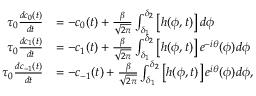<formula> <loc_0><loc_0><loc_500><loc_500>\begin{array} { r l } { \tau _ { 0 } \frac { d c _ { 0 } ( t ) } { d t } } & { = - c _ { 0 } ( t ) + \frac { \beta } { \sqrt { 2 \pi } } \int _ { \delta _ { 1 } } ^ { \delta _ { 2 } } \left [ h ( \phi , t ) \right ] d \phi } \\ { \tau _ { 0 } \frac { d c _ { 1 } ( t ) } { d t } } & { = - c _ { 1 } ( t ) + \frac { \beta } { \sqrt { 2 \pi } } \int _ { \delta _ { 1 } } ^ { \delta _ { 2 } } \left [ h ( \phi , t ) \right ] e ^ { - i \theta } ( \phi ) d \phi } \\ { \tau _ { 0 } \frac { d c _ { - 1 } ( t ) } { d t } } & { = - c _ { - 1 } ( t ) + \frac { \beta } { \sqrt { 2 \pi } } \int _ { \delta _ { 1 } } ^ { \delta _ { 2 } } \left [ h ( \phi , t ) \right ] e ^ { i \theta } ( \phi ) d \phi , } \end{array}</formula> 